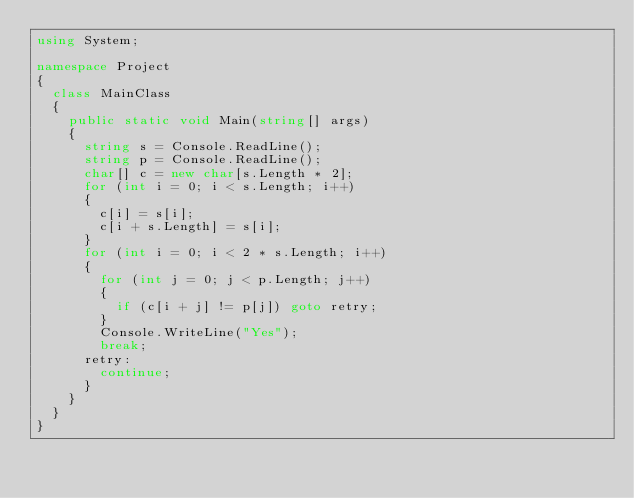Convert code to text. <code><loc_0><loc_0><loc_500><loc_500><_C#_>using System;

namespace Project
{
	class MainClass
	{
		public static void Main(string[] args)
		{
			string s = Console.ReadLine();
			string p = Console.ReadLine();
			char[] c = new char[s.Length * 2];
			for (int i = 0; i < s.Length; i++)
			{
				c[i] = s[i];
				c[i + s.Length] = s[i];
			}
			for (int i = 0; i < 2 * s.Length; i++)
			{
				for (int j = 0; j < p.Length; j++)
				{
					if (c[i + j] != p[j]) goto retry;
				}
				Console.WriteLine("Yes");
				break;
			retry:
				continue;
			}
		}
	}
}</code> 